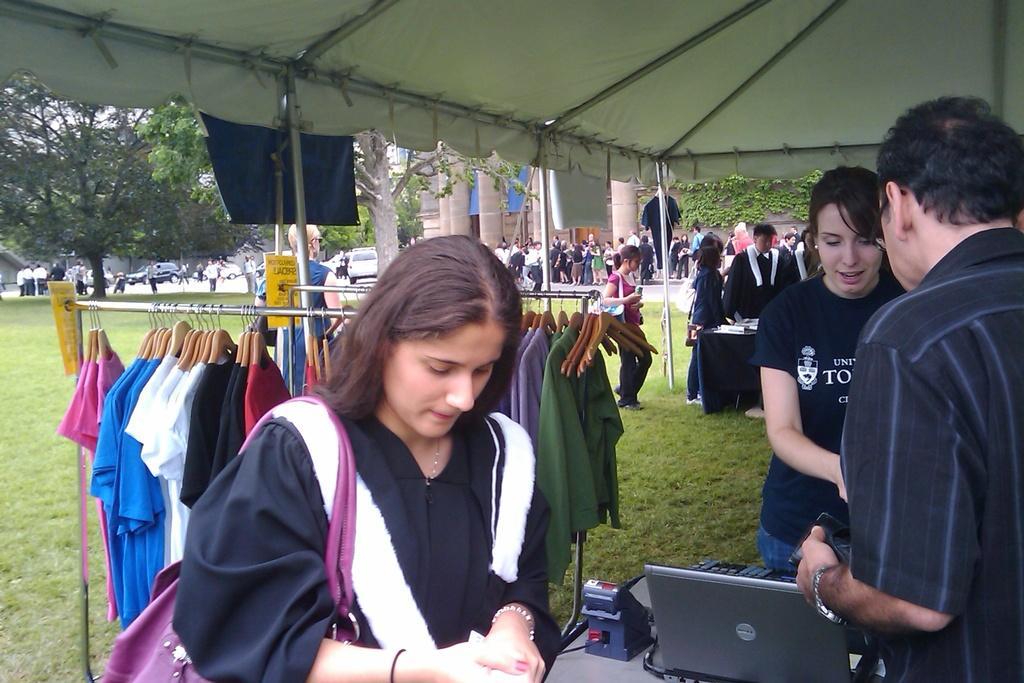In one or two sentences, can you explain what this image depicts? In this image I can see there are few persons standing under the tent , under the tent I can see hanger on the hanger I can see clothes and I can see a laptop kept on the table at the bottom and I can see trees visible in the middle and few persons and cars visible in front of the building. 